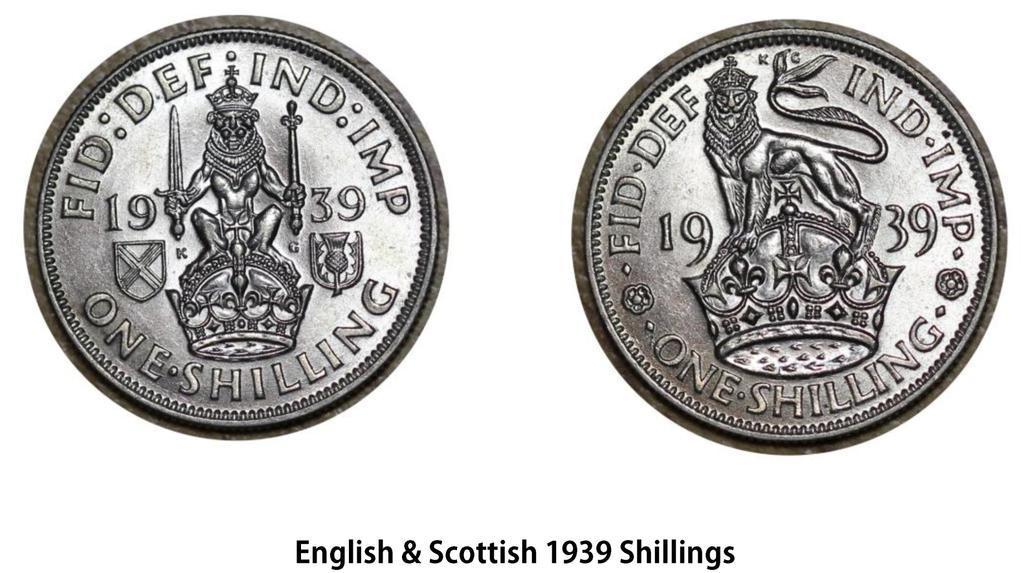<image>
Provide a brief description of the given image. A one shilling coin has a lion with a crown on it. 